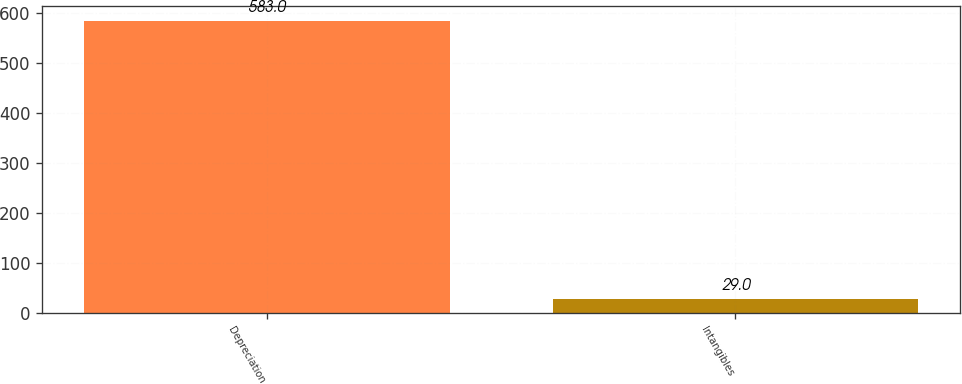Convert chart to OTSL. <chart><loc_0><loc_0><loc_500><loc_500><bar_chart><fcel>Depreciation<fcel>Intangibles<nl><fcel>583<fcel>29<nl></chart> 